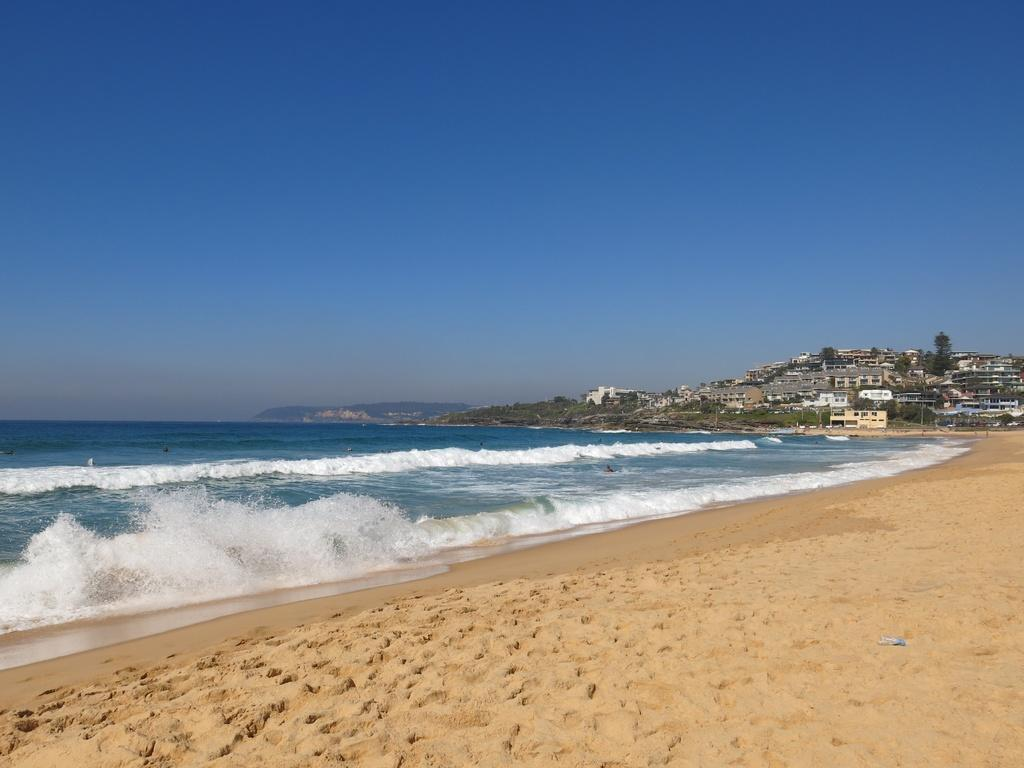What type of terrain is visible in the image? There is sand in the image. What else can be seen in the image besides sand? There is water, buildings, trees, and the sky visible in the image. Can you tell me how many rabbits are hopping in the water in the image? There are no rabbits present in the image; it features sand, water, buildings, trees, and the sky. Is there an actor performing a scene in the image? There is no actor or performance present in the image. 